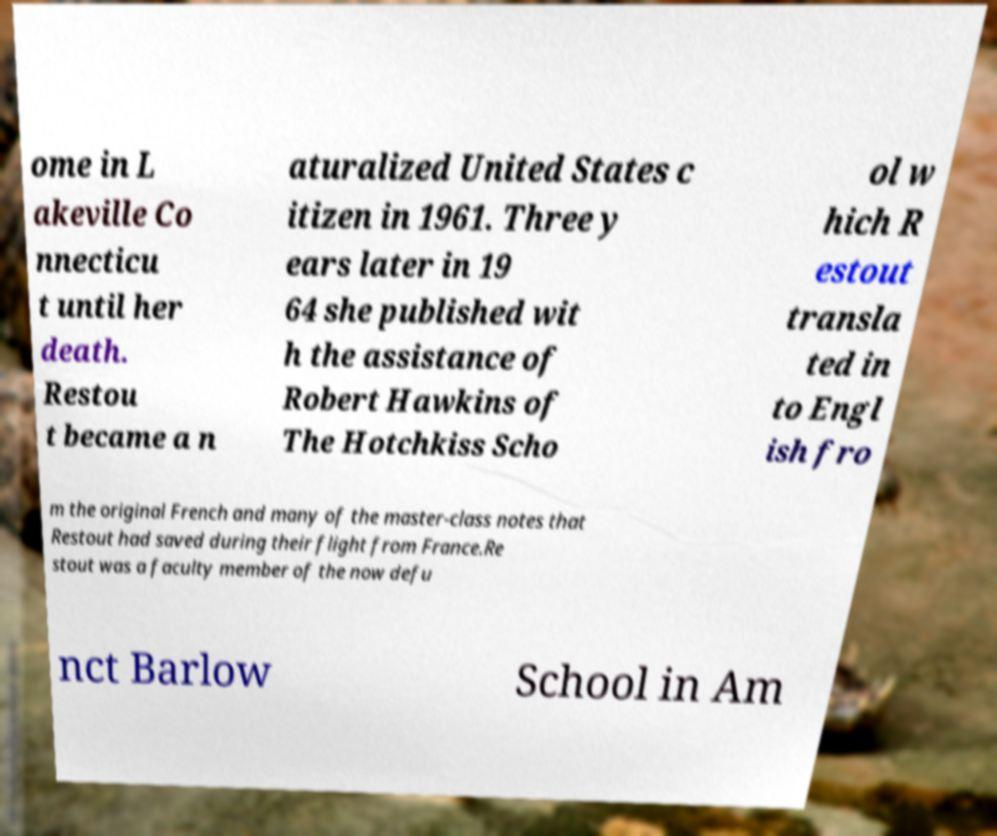I need the written content from this picture converted into text. Can you do that? ome in L akeville Co nnecticu t until her death. Restou t became a n aturalized United States c itizen in 1961. Three y ears later in 19 64 she published wit h the assistance of Robert Hawkins of The Hotchkiss Scho ol w hich R estout transla ted in to Engl ish fro m the original French and many of the master-class notes that Restout had saved during their flight from France.Re stout was a faculty member of the now defu nct Barlow School in Am 